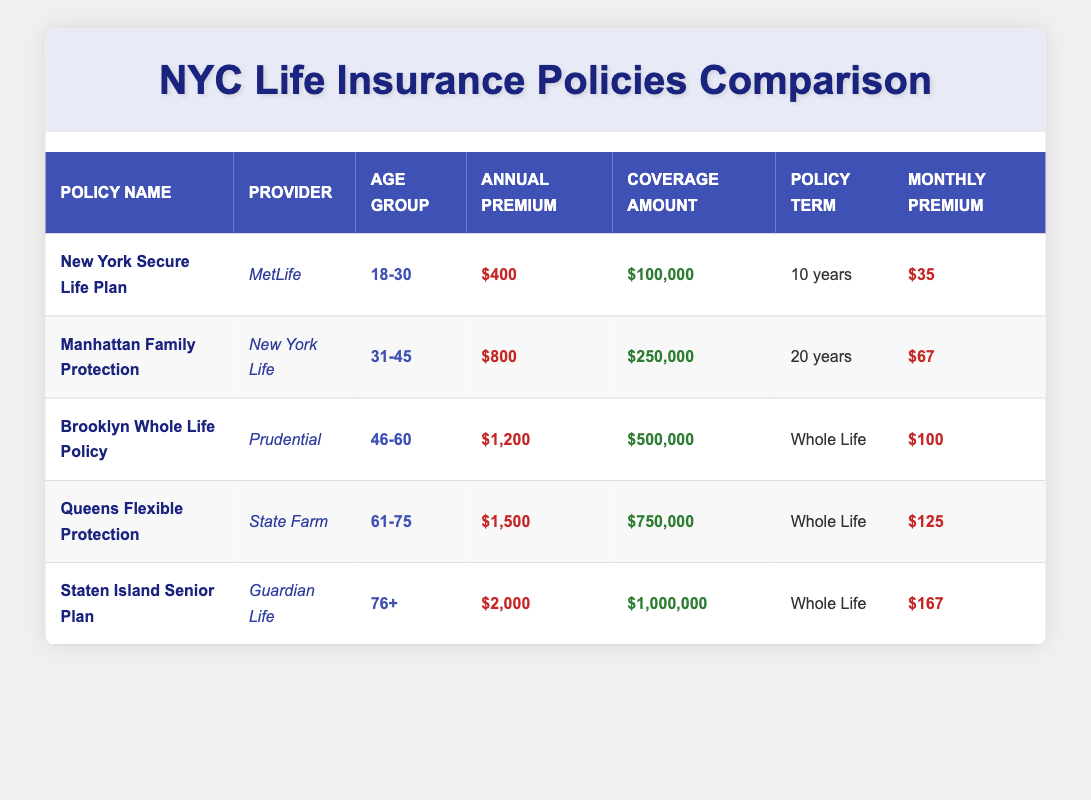What is the average annual premium for the "Brooklyn Whole Life Policy"? The annual premium for the "Brooklyn Whole Life Policy" is listed in the table as $1,200.
Answer: $1,200 Which policy has the highest coverage amount? In the table, the "Staten Island Senior Plan" offers a coverage amount of $1,000,000, which is the highest compared to other policies.
Answer: Staten Island Senior Plan What is the total monthly premium for the “Queens Flexible Protection” and “Staten Island Senior Plan”? The monthly premium for “Queens Flexible Protection” is $125, and for “Staten Island Senior Plan” it is $167. Adding these together gives $125 + $167 = $292.
Answer: $292 Is the average annual premium for all policies above $1,000? To find the average, sum the annual premiums: $400 + $800 + $1,200 + $1,500 + $2,000 = $5,900. There are 5 policies, so the average is $5,900 / 5 = $1,180. Since $1,180 is above $1,000, the answer is yes.
Answer: Yes Which policy has the lowest monthly premium and what is it? The "New York Secure Life Plan" has the lowest monthly premium of $35, as shown in the table.
Answer: $35 If a person chooses the "Manhattan Family Protection" policy, how much would they pay in total over its policy term? The annual premium for this policy is $800. Since the policy term is 20 years, the total cost would be calculated as $800 * 20 = $16,000.
Answer: $16,000 Does the "Queens Flexible Protection" policy have a higher average annual premium than the "Brooklyn Whole Life Policy"? The average annual premium for "Queens Flexible Protection" is $1,500, while for "Brooklyn Whole Life Policy" it is $1,200. Since $1,500 is greater than $1,200, the answer is yes.
Answer: Yes What is the difference in coverage amount between the "New York Secure Life Plan" and the "Staten Island Senior Plan"? The "New York Secure Life Plan" offers $100,000 in coverage, while the "Staten Island Senior Plan" offers $1,000,000. The difference is $1,000,000 - $100,000 = $900,000.
Answer: $900,000 What is the average annual premium for policies in the age group 31-45? Only one policy, the "Manhattan Family Protection," falls under this age group with an annual premium of $800. Since there's only one value, the average is simply $800.
Answer: $800 